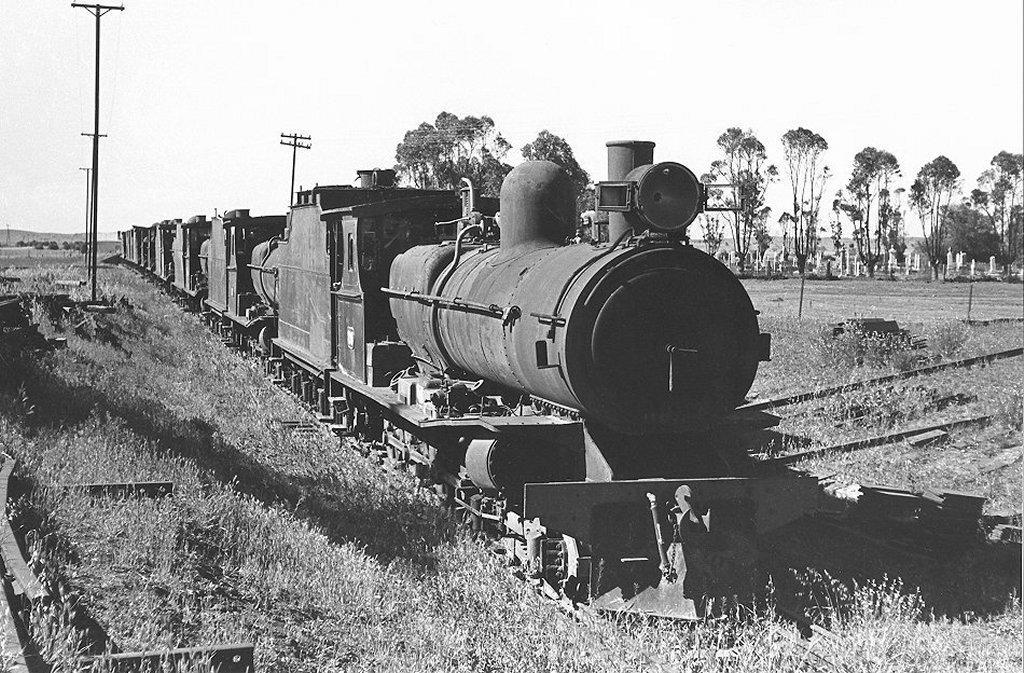In one or two sentences, can you explain what this image depicts? In this black and white image there is a train on the track and there are a few poles on the surface of the grass. In the background there are trees and the sky. 